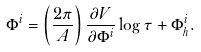Convert formula to latex. <formula><loc_0><loc_0><loc_500><loc_500>\Phi ^ { i } = \left ( \frac { 2 \pi } { A } \right ) \frac { \partial V } { \partial \Phi ^ { i } } \log \tau + \Phi ^ { i } _ { h } .</formula> 